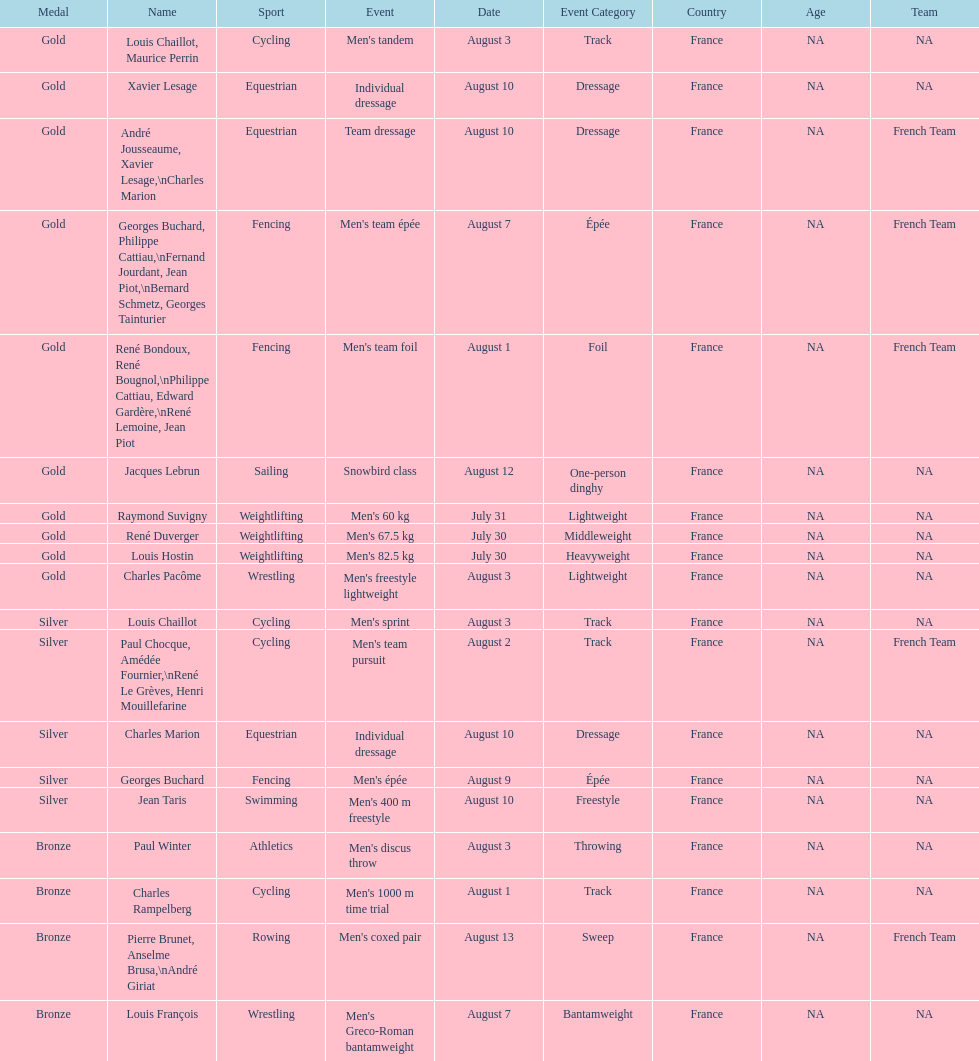What event is listed right before team dressage? Individual dressage. 